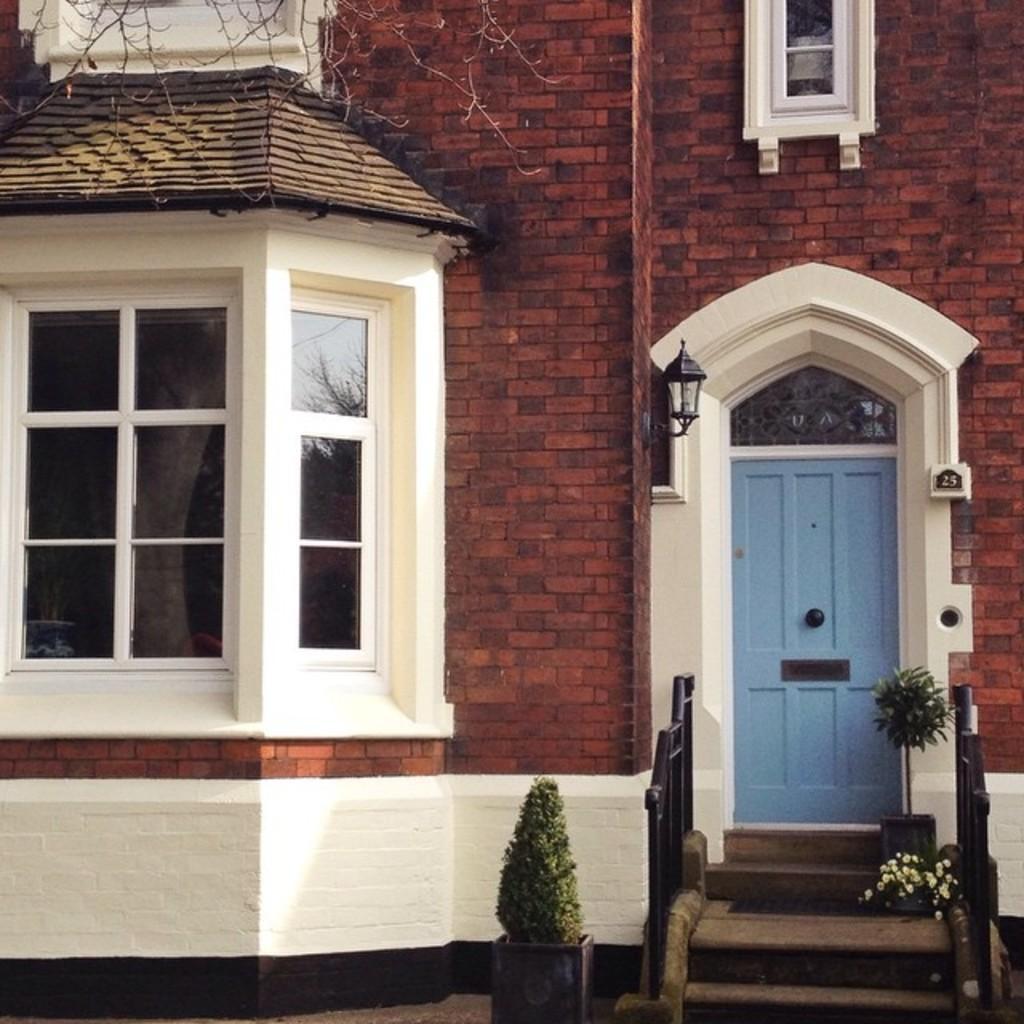Please provide a concise description of this image. In this picture I can observe a building. On the left side I can observe windows. On the right side there is a blue color door. 